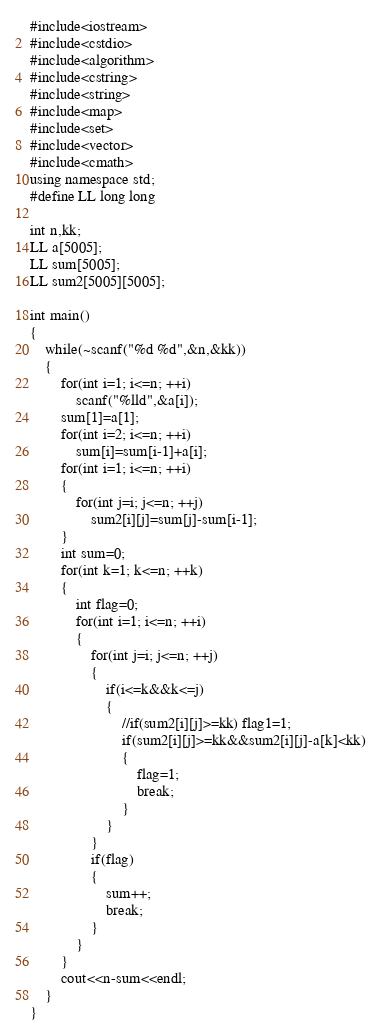Convert code to text. <code><loc_0><loc_0><loc_500><loc_500><_C++_>#include<iostream>
#include<cstdio>
#include<algorithm>
#include<cstring>
#include<string>
#include<map>
#include<set>
#include<vector>
#include<cmath>
using namespace std;
#define LL long long

int n,kk;
LL a[5005];
LL sum[5005];
LL sum2[5005][5005];

int main()
{
    while(~scanf("%d %d",&n,&kk))
    {
        for(int i=1; i<=n; ++i)
            scanf("%lld",&a[i]);
        sum[1]=a[1];
        for(int i=2; i<=n; ++i)
            sum[i]=sum[i-1]+a[i];
        for(int i=1; i<=n; ++i)
        {
            for(int j=i; j<=n; ++j)
                sum2[i][j]=sum[j]-sum[i-1];
        }
        int sum=0;
        for(int k=1; k<=n; ++k)
        {
            int flag=0;
            for(int i=1; i<=n; ++i)
            {
                for(int j=i; j<=n; ++j)
                {
                    if(i<=k&&k<=j)
                    {
                        //if(sum2[i][j]>=kk) flag1=1;
                        if(sum2[i][j]>=kk&&sum2[i][j]-a[k]<kk)
                        {
                            flag=1;
                            break;
                        }
                    }
                }
                if(flag)
                {
                    sum++;
                    break;
                }
            }
        }
        cout<<n-sum<<endl;
    }
}
</code> 